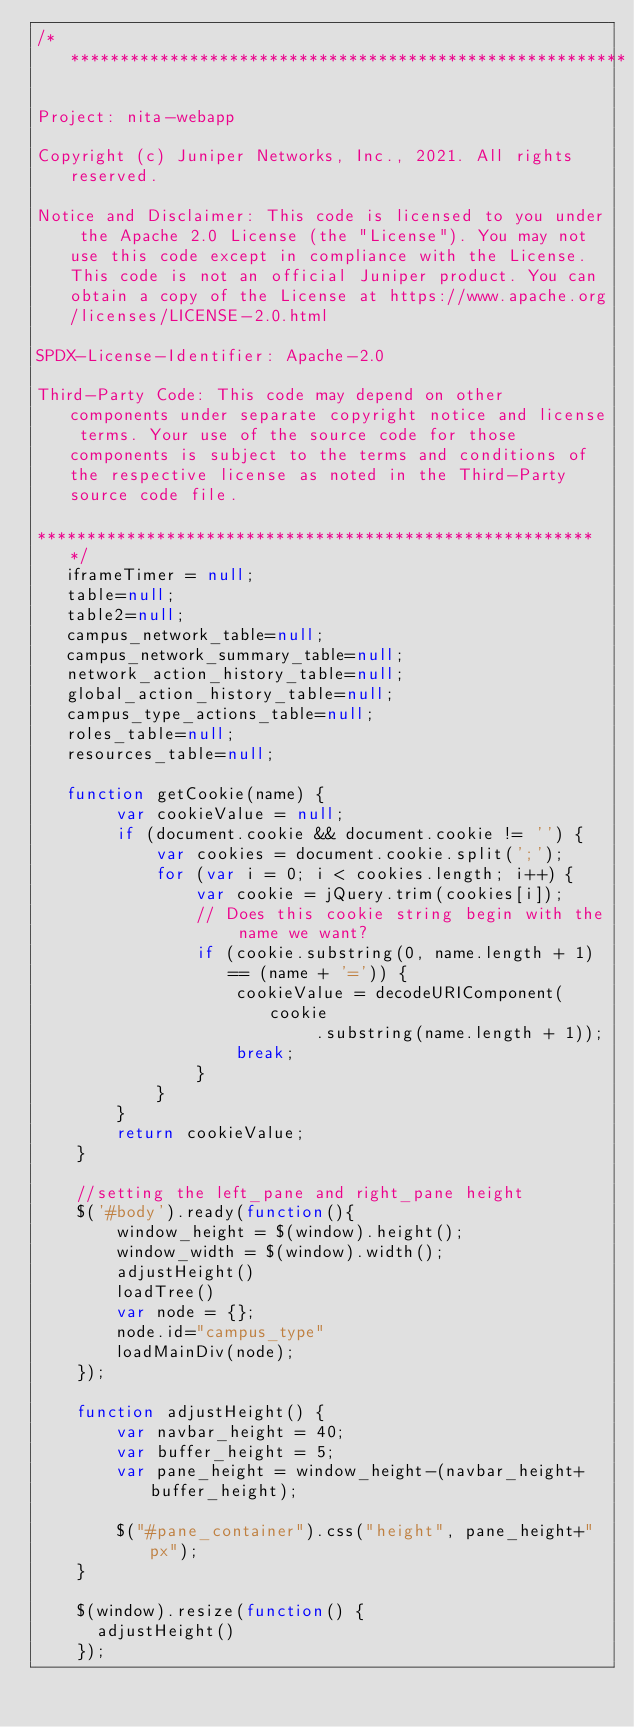<code> <loc_0><loc_0><loc_500><loc_500><_JavaScript_>/* ********************************************************

Project: nita-webapp

Copyright (c) Juniper Networks, Inc., 2021. All rights reserved.

Notice and Disclaimer: This code is licensed to you under the Apache 2.0 License (the "License"). You may not use this code except in compliance with the License. This code is not an official Juniper product. You can obtain a copy of the License at https://www.apache.org/licenses/LICENSE-2.0.html

SPDX-License-Identifier: Apache-2.0

Third-Party Code: This code may depend on other components under separate copyright notice and license terms. Your use of the source code for those components is subject to the terms and conditions of the respective license as noted in the Third-Party source code file.

******************************************************** */
   iframeTimer = null;
   table=null;
   table2=null;
   campus_network_table=null;
   campus_network_summary_table=null;
   network_action_history_table=null;
   global_action_history_table=null;
   campus_type_actions_table=null;
   roles_table=null;
   resources_table=null;

   function getCookie(name) {
	    var cookieValue = null;
	    if (document.cookie && document.cookie != '') {
		    var cookies = document.cookie.split(';');
		    for (var i = 0; i < cookies.length; i++) {
			    var cookie = jQuery.trim(cookies[i]);
			    // Does this cookie string begin with the name we want?
			    if (cookie.substring(0, name.length + 1) == (name + '=')) {
				    cookieValue = decodeURIComponent(cookie
						    .substring(name.length + 1));
				    break;
			    }
		    }
	    }
	    return cookieValue;
    }

    //setting the left_pane and right_pane height
    $('#body').ready(function(){
    	window_height = $(window).height();
    	window_width = $(window).width();
        adjustHeight()
        loadTree()
        var node = {};
        node.id="campus_type"
        loadMainDiv(node);
    });

    function adjustHeight() {
        var navbar_height = 40;
        var buffer_height = 5;
        var pane_height = window_height-(navbar_height+buffer_height);

        $("#pane_container").css("height", pane_height+"px");
    }

    $(window).resize(function() {
      adjustHeight()
    });
</code> 